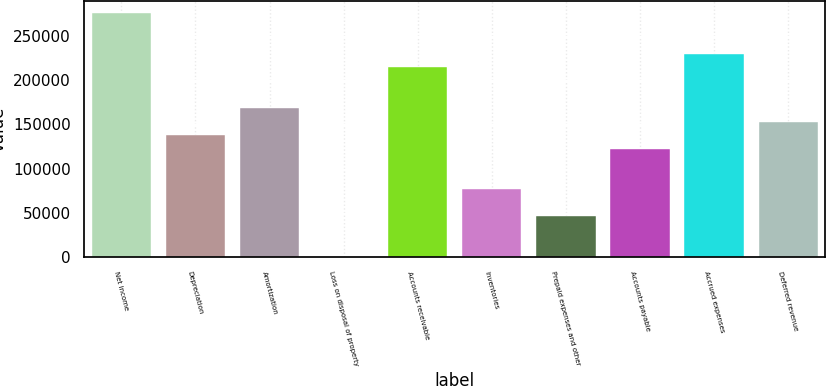<chart> <loc_0><loc_0><loc_500><loc_500><bar_chart><fcel>Net income<fcel>Depreciation<fcel>Amortization<fcel>Loss on disposal of property<fcel>Accounts receivable<fcel>Inventories<fcel>Prepaid expenses and other<fcel>Accounts payable<fcel>Accrued expenses<fcel>Deferred revenue<nl><fcel>275263<fcel>137998<fcel>168502<fcel>734<fcel>214256<fcel>76992<fcel>46488.8<fcel>122747<fcel>229508<fcel>153250<nl></chart> 